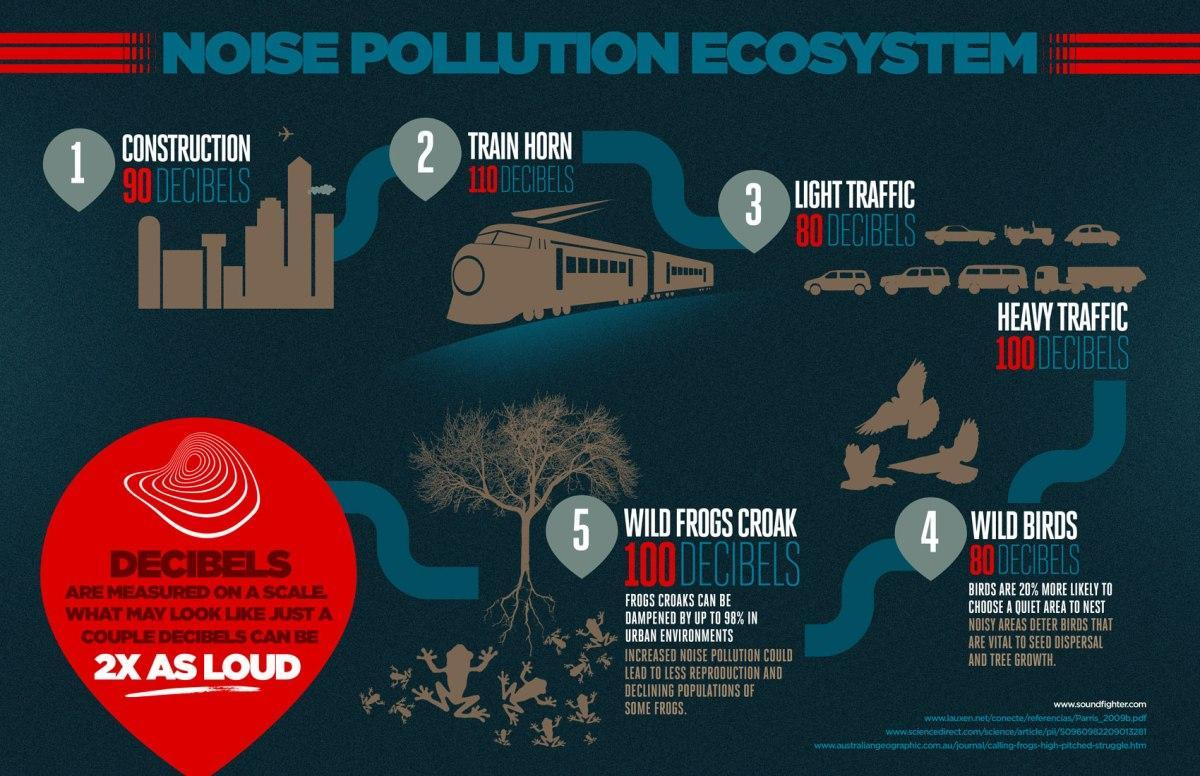Which causes the highest amount of noise pollution, road vehicles, wild frogs, or trains?
Answer the question with a short phrase. trains What is the noise pollution caused due construction in Decibels, 80, 90, or 110? 90 What are main causes of 80 dB noise pollution? LIGHT TRAFFIC, WILD BIRDS 